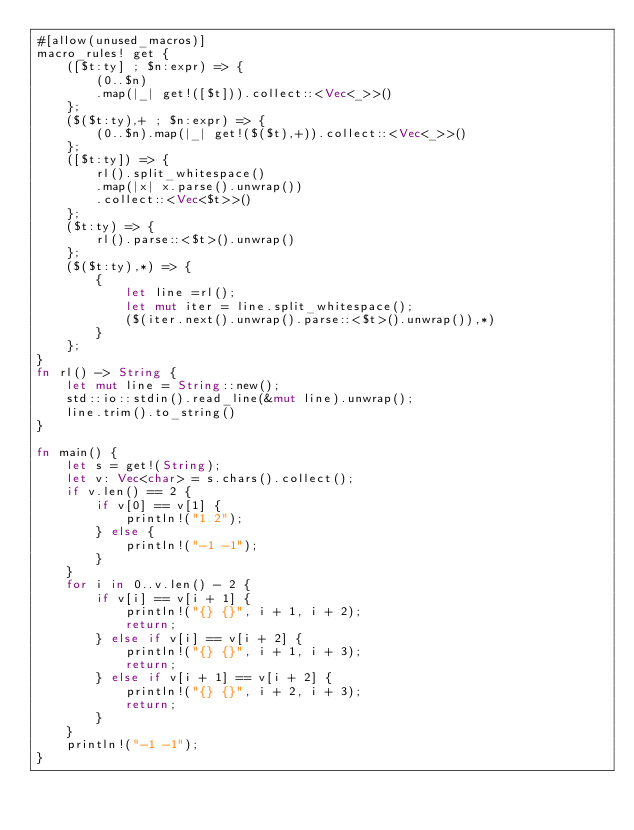<code> <loc_0><loc_0><loc_500><loc_500><_Rust_>#[allow(unused_macros)]
macro_rules! get {
    ([$t:ty] ; $n:expr) => {
        (0..$n)
        .map(|_| get!([$t])).collect::<Vec<_>>()
    };
    ($($t:ty),+ ; $n:expr) => {
        (0..$n).map(|_| get!($($t),+)).collect::<Vec<_>>()
    };
    ([$t:ty]) => {
        rl().split_whitespace()
        .map(|x| x.parse().unwrap())
        .collect::<Vec<$t>>()
    };
    ($t:ty) => {
        rl().parse::<$t>().unwrap()
    };
    ($($t:ty),*) => {
        {
            let line =rl();
            let mut iter = line.split_whitespace();
            ($(iter.next().unwrap().parse::<$t>().unwrap()),*)
        }
    };
}
fn rl() -> String {
    let mut line = String::new();
    std::io::stdin().read_line(&mut line).unwrap();
    line.trim().to_string()
}

fn main() {
    let s = get!(String);
    let v: Vec<char> = s.chars().collect();
    if v.len() == 2 {
        if v[0] == v[1] {
            println!("1 2");
        } else {
            println!("-1 -1");
        }
    }
    for i in 0..v.len() - 2 {
        if v[i] == v[i + 1] {
            println!("{} {}", i + 1, i + 2);
            return;
        } else if v[i] == v[i + 2] {
            println!("{} {}", i + 1, i + 3);
            return;
        } else if v[i + 1] == v[i + 2] {
            println!("{} {}", i + 2, i + 3);
            return;
        }
    }
    println!("-1 -1");
}
</code> 